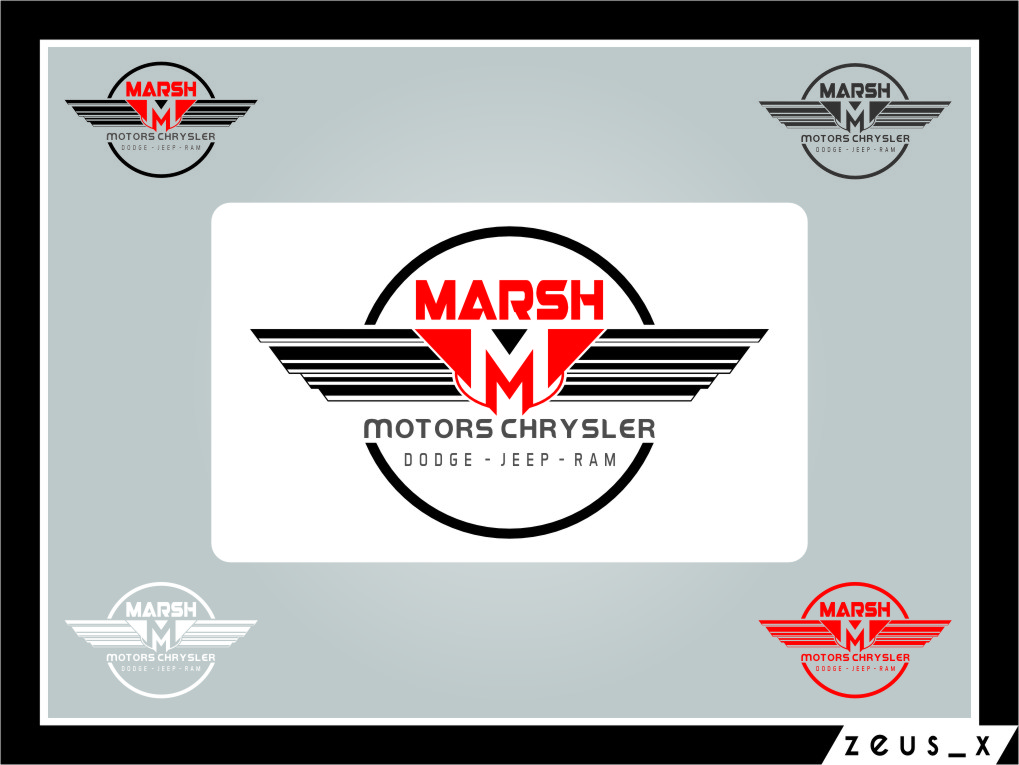How does the color scheme of the logo enhance its connection to the automotive industry? The color scheme of the logo, featuring bold red and black, enhances its automotive connection by conveying energy and strength. Red often symbolizes power and passion, qualities highly valued in the automotive industry. Black adds a level of sophistication and elegance. Together, these colors create a visually striking logo that stands out, asserting the brand's dynamic and high-performance identity typical in the car market. 